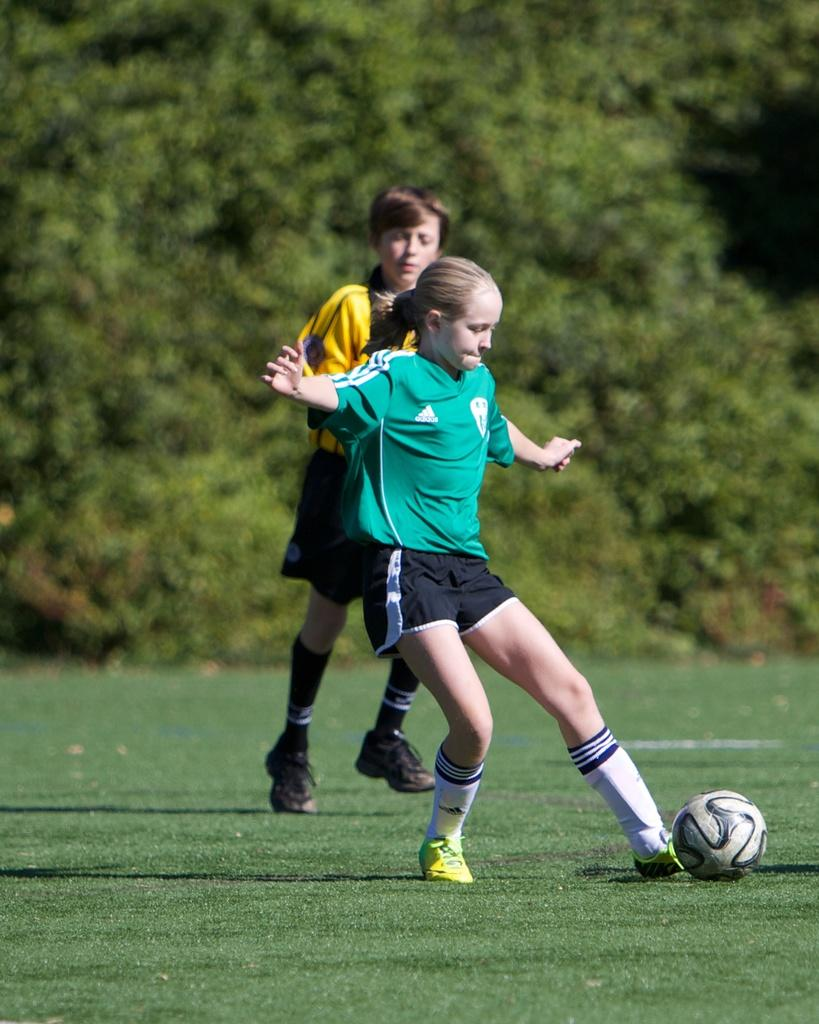Who are the people in the image? There is a girl and a boy in the image. What object can be seen with them? There is a football in the image. What can be seen in the background of the image? There are trees in the background of the image. Can you see any ghosts in the image? No, there are no ghosts present in the image. How many ladybugs are visible on the football? There are no ladybugs visible on the football in the image. 